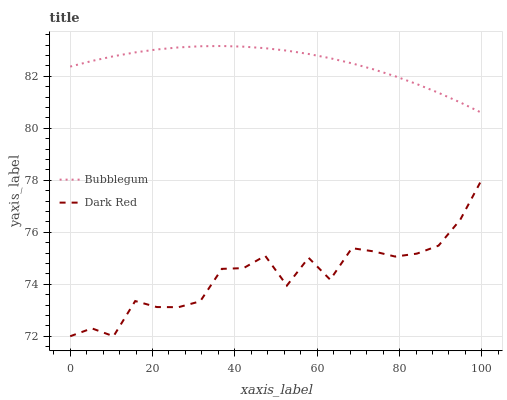Does Dark Red have the minimum area under the curve?
Answer yes or no. Yes. Does Bubblegum have the maximum area under the curve?
Answer yes or no. Yes. Does Bubblegum have the minimum area under the curve?
Answer yes or no. No. Is Bubblegum the smoothest?
Answer yes or no. Yes. Is Dark Red the roughest?
Answer yes or no. Yes. Is Bubblegum the roughest?
Answer yes or no. No. Does Dark Red have the lowest value?
Answer yes or no. Yes. Does Bubblegum have the lowest value?
Answer yes or no. No. Does Bubblegum have the highest value?
Answer yes or no. Yes. Is Dark Red less than Bubblegum?
Answer yes or no. Yes. Is Bubblegum greater than Dark Red?
Answer yes or no. Yes. Does Dark Red intersect Bubblegum?
Answer yes or no. No. 